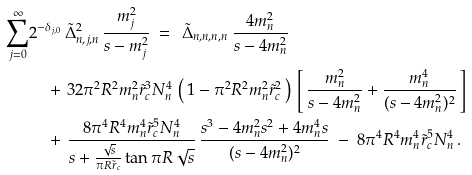<formula> <loc_0><loc_0><loc_500><loc_500>\sum _ { j = 0 } ^ { \infty } & 2 ^ { - \delta _ { j , 0 } } \, \tilde { \Delta } ^ { 2 } _ { n , j , n } \, \frac { m _ { j } ^ { 2 } } { s - m _ { j } ^ { 2 } } \ = \ \, \tilde { \Delta } _ { n , n , n , n } \, \frac { 4 m _ { n } ^ { 2 } } { s - 4 m _ { n } ^ { 2 } } \\ & \quad + \, 3 2 \pi ^ { 2 } R ^ { 2 } m _ { n } ^ { 2 } \tilde { r } _ { c } ^ { 3 } N _ { n } ^ { 4 } \, \left ( \, 1 - \pi ^ { 2 } R ^ { 2 } m _ { n } ^ { 2 } \tilde { r } _ { c } ^ { 2 } \, \right ) \, \left [ \, \frac { m _ { n } ^ { 2 } } { s - 4 m _ { n } ^ { 2 } } + \frac { m _ { n } ^ { 4 } } { ( s - 4 m _ { n } ^ { 2 } ) ^ { 2 } } \, \right ] \\ & \quad + \, \frac { 8 \pi ^ { 4 } R ^ { 4 } m _ { n } ^ { 4 } \tilde { r } _ { c } ^ { 5 } N _ { n } ^ { 4 } } { s + \frac { \sqrt { s } } { \pi R \tilde { r } _ { c } } \tan \pi R \sqrt { s } } \, \frac { s ^ { 3 } - 4 m _ { n } ^ { 2 } s ^ { 2 } + 4 m _ { n } ^ { 4 } s } { ( s - 4 m _ { n } ^ { 2 } ) ^ { 2 } } \ - \ 8 \pi ^ { 4 } R ^ { 4 } m _ { n } ^ { 4 } \tilde { r } _ { c } ^ { 5 } N _ { n } ^ { 4 } \, .</formula> 